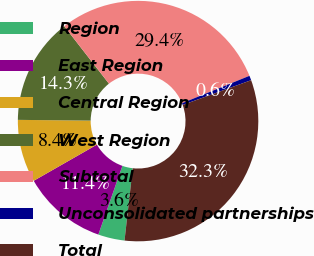Convert chart to OTSL. <chart><loc_0><loc_0><loc_500><loc_500><pie_chart><fcel>Region<fcel>East Region<fcel>Central Region<fcel>West Region<fcel>Subtotal<fcel>Unconsolidated partnerships<fcel>Total<nl><fcel>3.56%<fcel>11.37%<fcel>8.43%<fcel>14.31%<fcel>29.38%<fcel>0.62%<fcel>32.32%<nl></chart> 